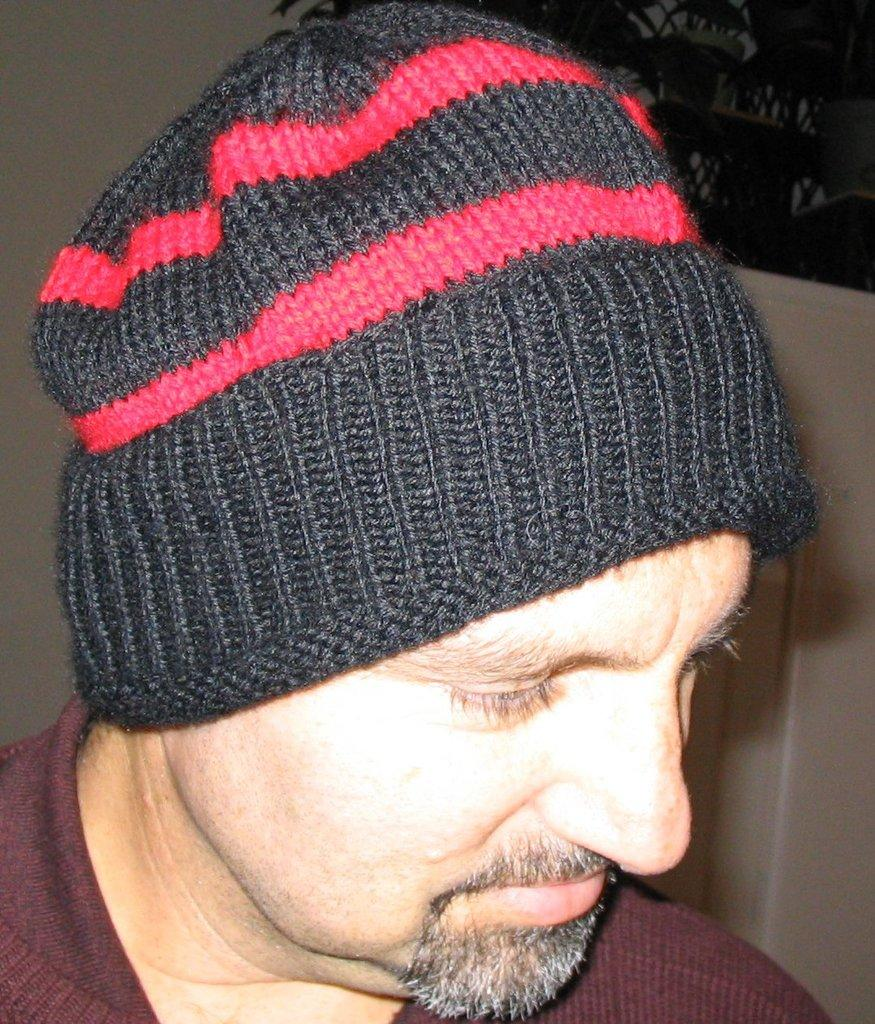What is present in the image? There is a person in the image. Can you describe the person's attire? The person is wearing a cap. How many sponges are visible in the image? There are no sponges present in the image. What breed of dogs can be seen in the image? There are no dogs present in the image. 